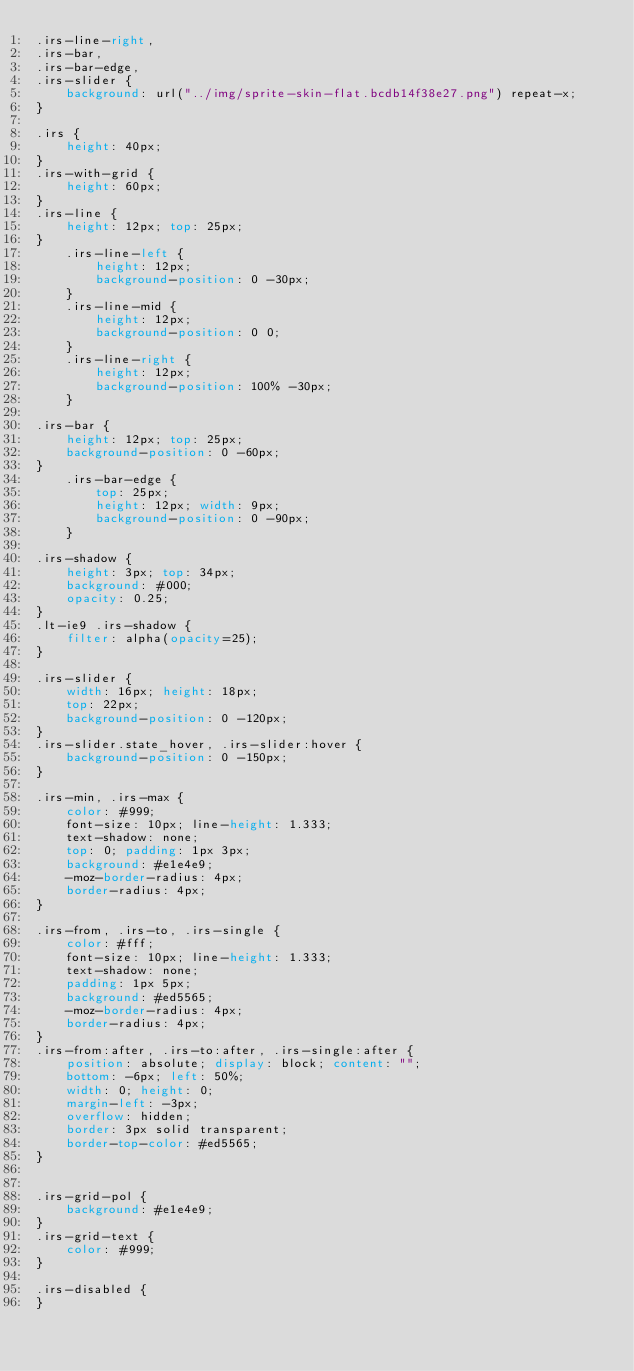Convert code to text. <code><loc_0><loc_0><loc_500><loc_500><_CSS_>.irs-line-right,
.irs-bar,
.irs-bar-edge,
.irs-slider {
    background: url("../img/sprite-skin-flat.bcdb14f38e27.png") repeat-x;
}

.irs {
    height: 40px;
}
.irs-with-grid {
    height: 60px;
}
.irs-line {
    height: 12px; top: 25px;
}
    .irs-line-left {
        height: 12px;
        background-position: 0 -30px;
    }
    .irs-line-mid {
        height: 12px;
        background-position: 0 0;
    }
    .irs-line-right {
        height: 12px;
        background-position: 100% -30px;
    }

.irs-bar {
    height: 12px; top: 25px;
    background-position: 0 -60px;
}
    .irs-bar-edge {
        top: 25px;
        height: 12px; width: 9px;
        background-position: 0 -90px;
    }

.irs-shadow {
    height: 3px; top: 34px;
    background: #000;
    opacity: 0.25;
}
.lt-ie9 .irs-shadow {
    filter: alpha(opacity=25);
}

.irs-slider {
    width: 16px; height: 18px;
    top: 22px;
    background-position: 0 -120px;
}
.irs-slider.state_hover, .irs-slider:hover {
    background-position: 0 -150px;
}

.irs-min, .irs-max {
    color: #999;
    font-size: 10px; line-height: 1.333;
    text-shadow: none;
    top: 0; padding: 1px 3px;
    background: #e1e4e9;
    -moz-border-radius: 4px;
    border-radius: 4px;
}

.irs-from, .irs-to, .irs-single {
    color: #fff;
    font-size: 10px; line-height: 1.333;
    text-shadow: none;
    padding: 1px 5px;
    background: #ed5565;
    -moz-border-radius: 4px;
    border-radius: 4px;
}
.irs-from:after, .irs-to:after, .irs-single:after {
    position: absolute; display: block; content: "";
    bottom: -6px; left: 50%;
    width: 0; height: 0;
    margin-left: -3px;
    overflow: hidden;
    border: 3px solid transparent;
    border-top-color: #ed5565;
}


.irs-grid-pol {
    background: #e1e4e9;
}
.irs-grid-text {
    color: #999;
}

.irs-disabled {
}
</code> 